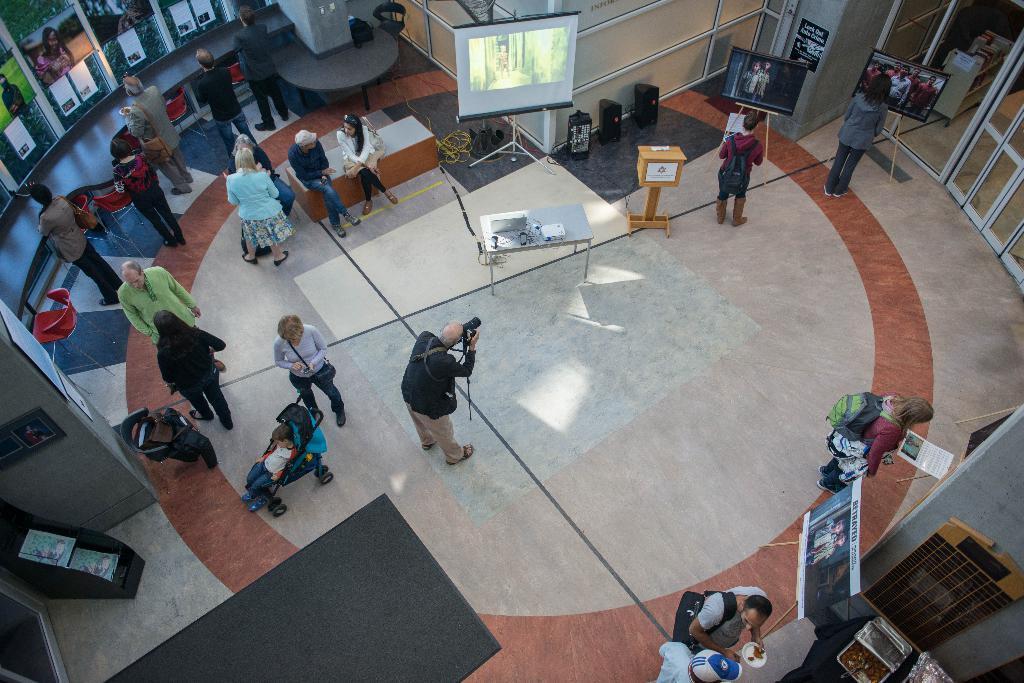Could you give a brief overview of what you see in this image? In this image I can see number of people are standing, I can also see few of them are carrying bags and here a man is holding a camera. Here I can see a projector's screen and a laptop on this table. 